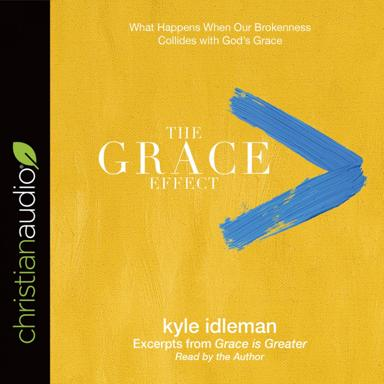What does the phrase 'What Happens When Our Brokenness Collides with God's Grace' suggest about the likely content of this audiobook? The phrase implies a deep exploration of the moments when human frailty and setbacks meet the transformative power of divine grace. The content is likely to address real-life stories or parables where grace acts as the catalyst for healing, redemption, and turning points in people's lives, illustrating how grace can redefine our experiences and offer new paths forward. 